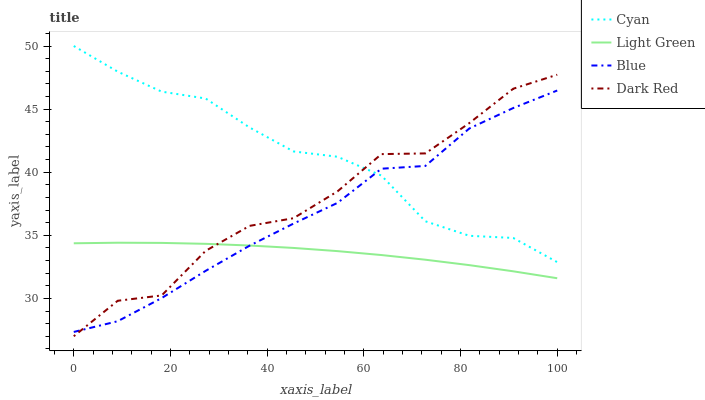Does Light Green have the minimum area under the curve?
Answer yes or no. Yes. Does Cyan have the maximum area under the curve?
Answer yes or no. Yes. Does Cyan have the minimum area under the curve?
Answer yes or no. No. Does Light Green have the maximum area under the curve?
Answer yes or no. No. Is Light Green the smoothest?
Answer yes or no. Yes. Is Dark Red the roughest?
Answer yes or no. Yes. Is Cyan the smoothest?
Answer yes or no. No. Is Cyan the roughest?
Answer yes or no. No. Does Dark Red have the lowest value?
Answer yes or no. Yes. Does Light Green have the lowest value?
Answer yes or no. No. Does Cyan have the highest value?
Answer yes or no. Yes. Does Light Green have the highest value?
Answer yes or no. No. Is Light Green less than Cyan?
Answer yes or no. Yes. Is Cyan greater than Light Green?
Answer yes or no. Yes. Does Dark Red intersect Cyan?
Answer yes or no. Yes. Is Dark Red less than Cyan?
Answer yes or no. No. Is Dark Red greater than Cyan?
Answer yes or no. No. Does Light Green intersect Cyan?
Answer yes or no. No. 